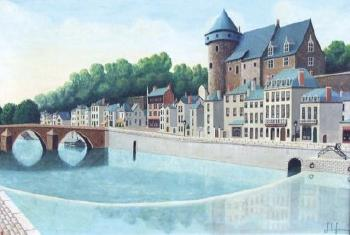If this town had a famous legend, what would it be? Legend tells of a mystical guardian living in the river beneath the bridges. This guardian, said to be a giant, benevolent fish with shimmering scales that glow under the moonlight, has protected the town for centuries. It is believed that during times of peril, the guardian rises from the depths to ward off threats and ensure the safety of the townspeople. The legend also speaks of a hidden treasure buried beneath the old castle, guarded by the spirit of an ancient warrior. Every year, on a specific night, a spectral figure is said to be seen wandering the town, leading the bravest of hearts to the potential fortune, but only those pure of heart and intent ever get close enough to try. Imagine an artist discovering a secret doorway in one of the buildings. What could they find behind it? Upon discovering a secret doorway in one of the buildings, the artist might find a hidden room filled with antique treasures. This concealed chamber could house an array of forgotten artifacts, from old manuscripts and rare books to ancient maps and paintings of past residents. Dust-covered furniture might suggest it was once a secret meeting place or a refuge during times of conflict. Perhaps the artist finds a collection of ornate, historically significant jewelry or a cache of letters unveiling untold stories of love and betrayal. Each item in the hidden room would tell a piece of a larger, mysterious history waiting to be uncovered. Based on the architecture and setting, what famous European landmarks or towns does this place remind you of? This town, with its charming mix of historic architecture and serene river setting, brings to mind places like Bruges in Belgium or Rothenburg ob der Tauber in Germany. The castle-like structure is reminiscent of the medieval strongholds found throughout Europe, especially in regions famous for their historical towns and picturesque landscapes. The arched bridges and riverside buildings evoke the scenic beauty of towns like Annecy in France or Ghent in Belgium, each blending natural and architectural beauty into a harmonious and inviting environment. 